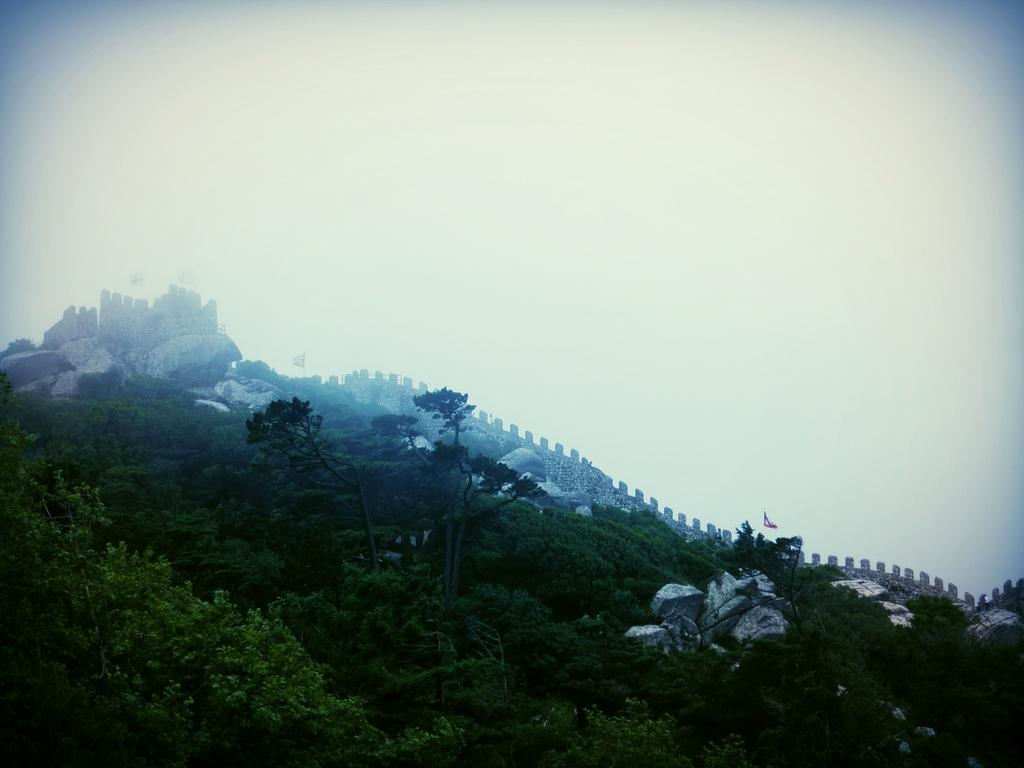What is located at the bottom of the image? There are trees and stones at the bottom of the image. What can be seen in the middle of the image? There are stones, a wall, and a flag in the middle of the image. What is visible at the top of the image? The sky is visible at the top of the image. How does the smoke affect the shade in the image? There is no smoke present in the image, so it cannot affect the shade. Can you describe the movement of the flag in the image? The flag is present in the image, but we cannot determine its movement based on the provided facts. 